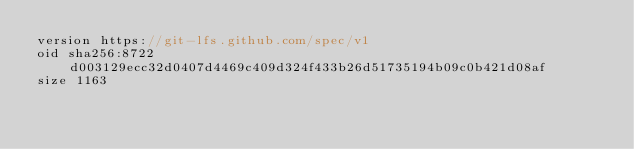Convert code to text. <code><loc_0><loc_0><loc_500><loc_500><_TypeScript_>version https://git-lfs.github.com/spec/v1
oid sha256:8722d003129ecc32d0407d4469c409d324f433b26d51735194b09c0b421d08af
size 1163
</code> 